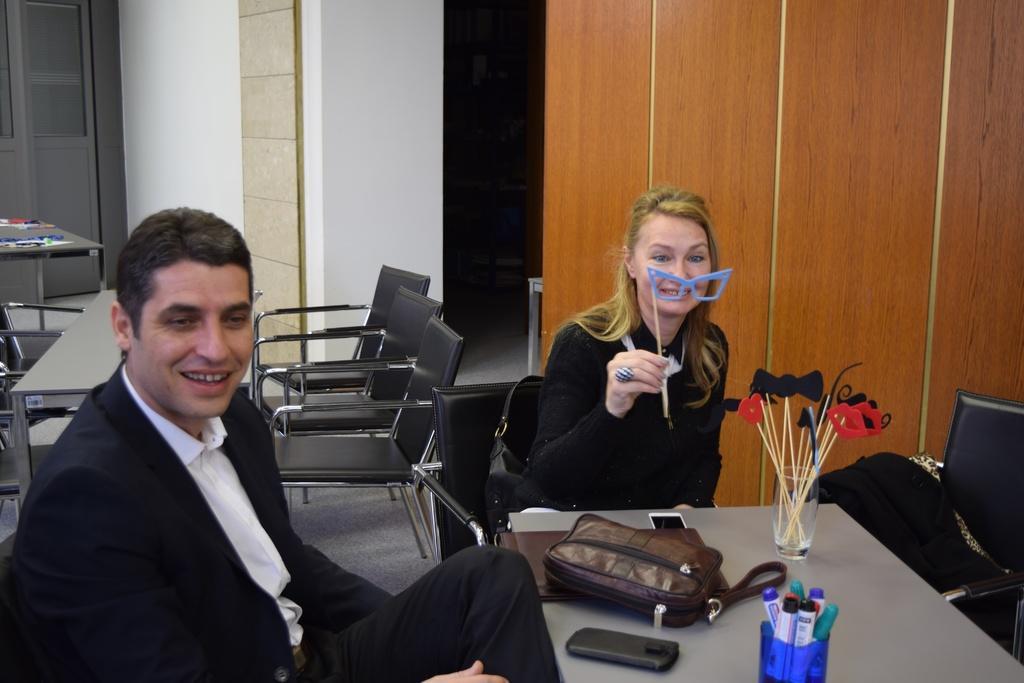In one or two sentences, can you explain what this image depicts? The image is inside the room. In the image there are two persons man and woman are sitting on chair in front of a table, on table we can see a glass,mobile,purse i background we can see a table and a wall. 